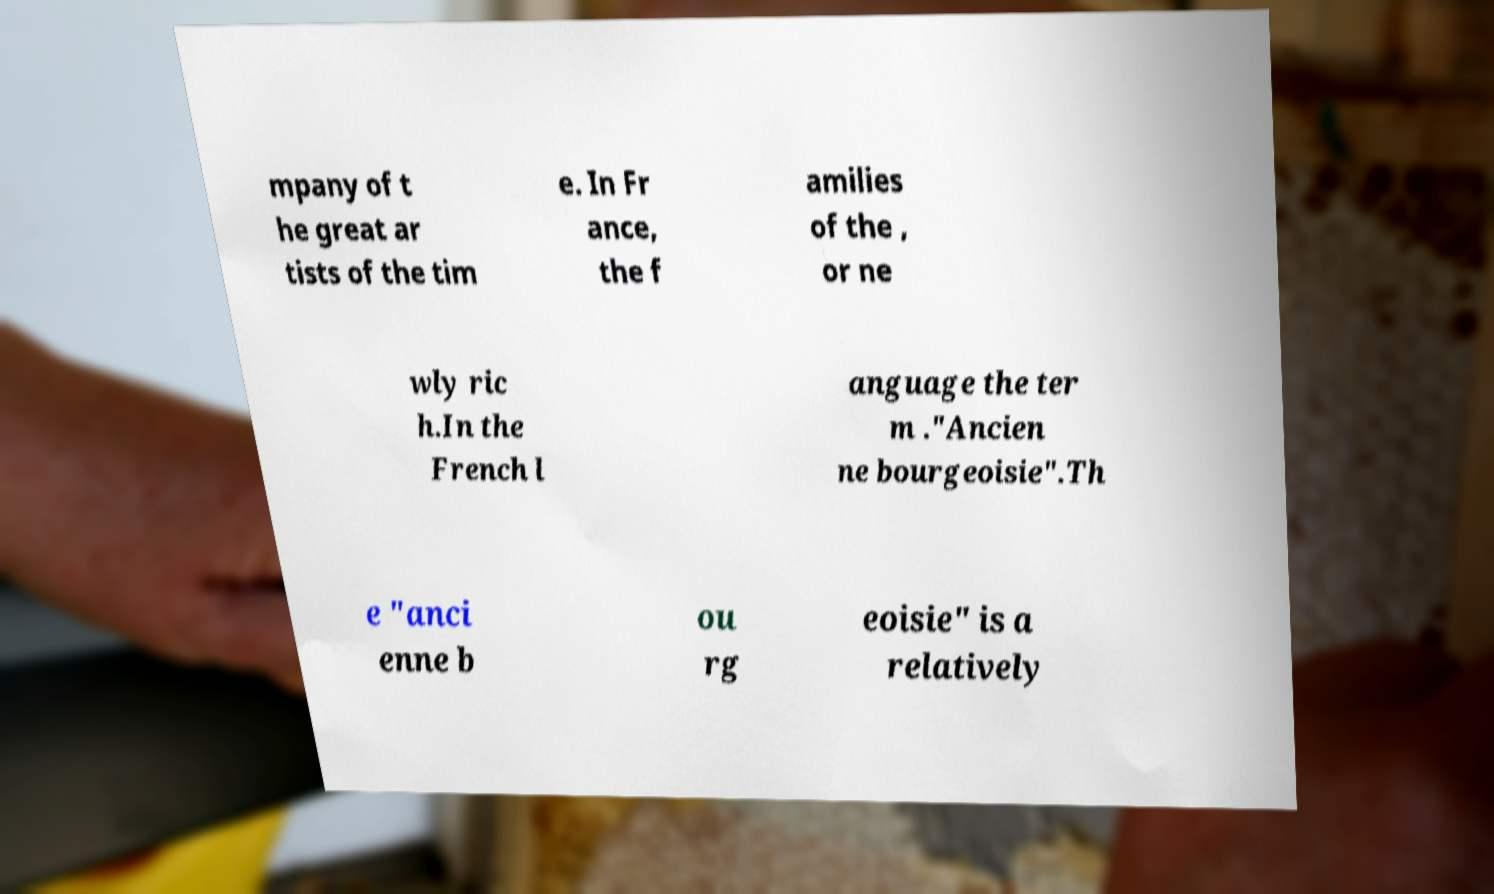For documentation purposes, I need the text within this image transcribed. Could you provide that? mpany of t he great ar tists of the tim e. In Fr ance, the f amilies of the , or ne wly ric h.In the French l anguage the ter m ."Ancien ne bourgeoisie".Th e "anci enne b ou rg eoisie" is a relatively 